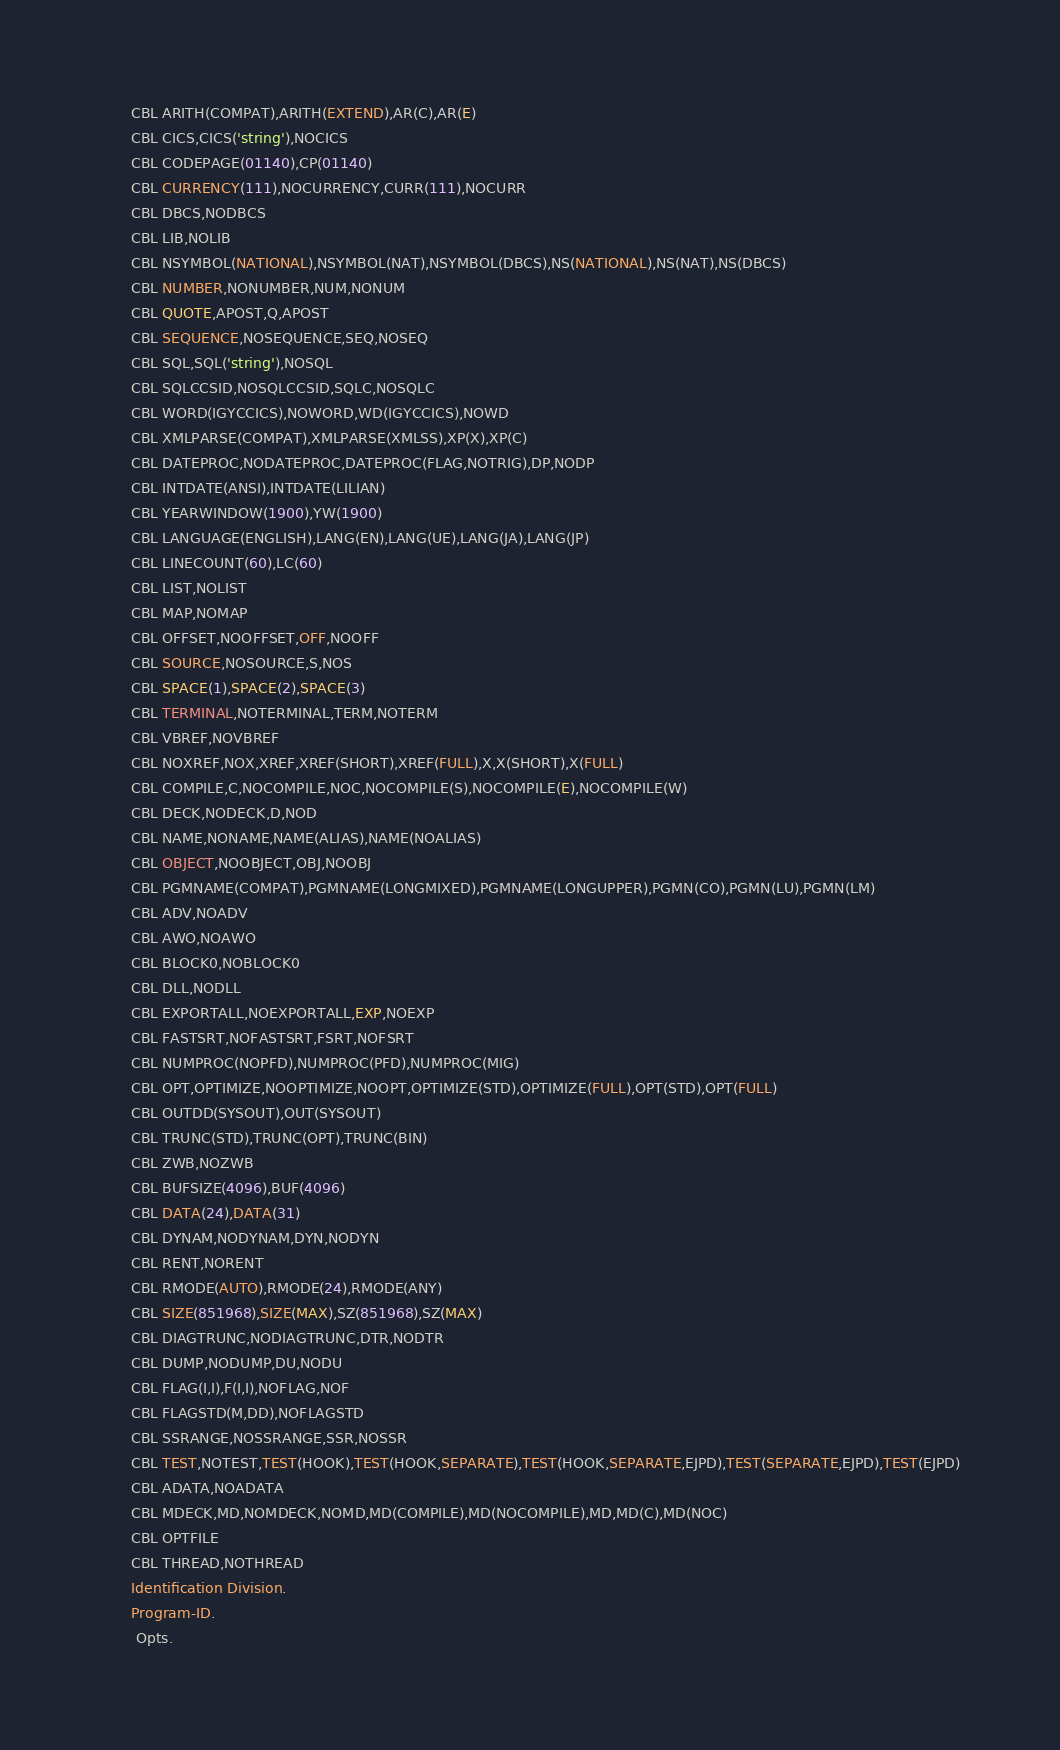<code> <loc_0><loc_0><loc_500><loc_500><_COBOL_>       CBL ARITH(COMPAT),ARITH(EXTEND),AR(C),AR(E)
       CBL CICS,CICS('string'),NOCICS
       CBL CODEPAGE(01140),CP(01140)
       CBL CURRENCY(111),NOCURRENCY,CURR(111),NOCURR
       CBL DBCS,NODBCS
       CBL LIB,NOLIB
       CBL NSYMBOL(NATIONAL),NSYMBOL(NAT),NSYMBOL(DBCS),NS(NATIONAL),NS(NAT),NS(DBCS)
       CBL NUMBER,NONUMBER,NUM,NONUM
       CBL QUOTE,APOST,Q,APOST
       CBL SEQUENCE,NOSEQUENCE,SEQ,NOSEQ
       CBL SQL,SQL('string'),NOSQL
       CBL SQLCCSID,NOSQLCCSID,SQLC,NOSQLC
       CBL WORD(IGYCCICS),NOWORD,WD(IGYCCICS),NOWD
       CBL XMLPARSE(COMPAT),XMLPARSE(XMLSS),XP(X),XP(C)
       CBL DATEPROC,NODATEPROC,DATEPROC(FLAG,NOTRIG),DP,NODP
       CBL INTDATE(ANSI),INTDATE(LILIAN)
       CBL YEARWINDOW(1900),YW(1900)
       CBL LANGUAGE(ENGLISH),LANG(EN),LANG(UE),LANG(JA),LANG(JP)
       CBL LINECOUNT(60),LC(60)
       CBL LIST,NOLIST
       CBL MAP,NOMAP
       CBL OFFSET,NOOFFSET,OFF,NOOFF
       CBL SOURCE,NOSOURCE,S,NOS
       CBL SPACE(1),SPACE(2),SPACE(3)
       CBL TERMINAL,NOTERMINAL,TERM,NOTERM
       CBL VBREF,NOVBREF
       CBL NOXREF,NOX,XREF,XREF(SHORT),XREF(FULL),X,X(SHORT),X(FULL)
       CBL COMPILE,C,NOCOMPILE,NOC,NOCOMPILE(S),NOCOMPILE(E),NOCOMPILE(W)
       CBL DECK,NODECK,D,NOD
       CBL NAME,NONAME,NAME(ALIAS),NAME(NOALIAS)
       CBL OBJECT,NOOBJECT,OBJ,NOOBJ
       CBL PGMNAME(COMPAT),PGMNAME(LONGMIXED),PGMNAME(LONGUPPER),PGMN(CO),PGMN(LU),PGMN(LM)
       CBL ADV,NOADV
       CBL AWO,NOAWO
       CBL BLOCK0,NOBLOCK0
       CBL DLL,NODLL
       CBL EXPORTALL,NOEXPORTALL,EXP,NOEXP
       CBL FASTSRT,NOFASTSRT,FSRT,NOFSRT
       CBL NUMPROC(NOPFD),NUMPROC(PFD),NUMPROC(MIG)
       CBL OPT,OPTIMIZE,NOOPTIMIZE,NOOPT,OPTIMIZE(STD),OPTIMIZE(FULL),OPT(STD),OPT(FULL)
       CBL OUTDD(SYSOUT),OUT(SYSOUT)
       CBL TRUNC(STD),TRUNC(OPT),TRUNC(BIN)
       CBL ZWB,NOZWB
       CBL BUFSIZE(4096),BUF(4096)
       CBL DATA(24),DATA(31)
       CBL DYNAM,NODYNAM,DYN,NODYN
       CBL RENT,NORENT
       CBL RMODE(AUTO),RMODE(24),RMODE(ANY)
       CBL SIZE(851968),SIZE(MAX),SZ(851968),SZ(MAX)
       CBL DIAGTRUNC,NODIAGTRUNC,DTR,NODTR
       CBL DUMP,NODUMP,DU,NODU
       CBL FLAG(I,I),F(I,I),NOFLAG,NOF
       CBL FLAGSTD(M,DD),NOFLAGSTD
       CBL SSRANGE,NOSSRANGE,SSR,NOSSR
       CBL TEST,NOTEST,TEST(HOOK),TEST(HOOK,SEPARATE),TEST(HOOK,SEPARATE,EJPD),TEST(SEPARATE,EJPD),TEST(EJPD)
       CBL ADATA,NOADATA
       CBL MDECK,MD,NOMDECK,NOMD,MD(COMPILE),MD(NOCOMPILE),MD,MD(C),MD(NOC)
       CBL OPTFILE
       CBL THREAD,NOTHREAD
       Identification Division.
       Program-ID.
        Opts.</code> 